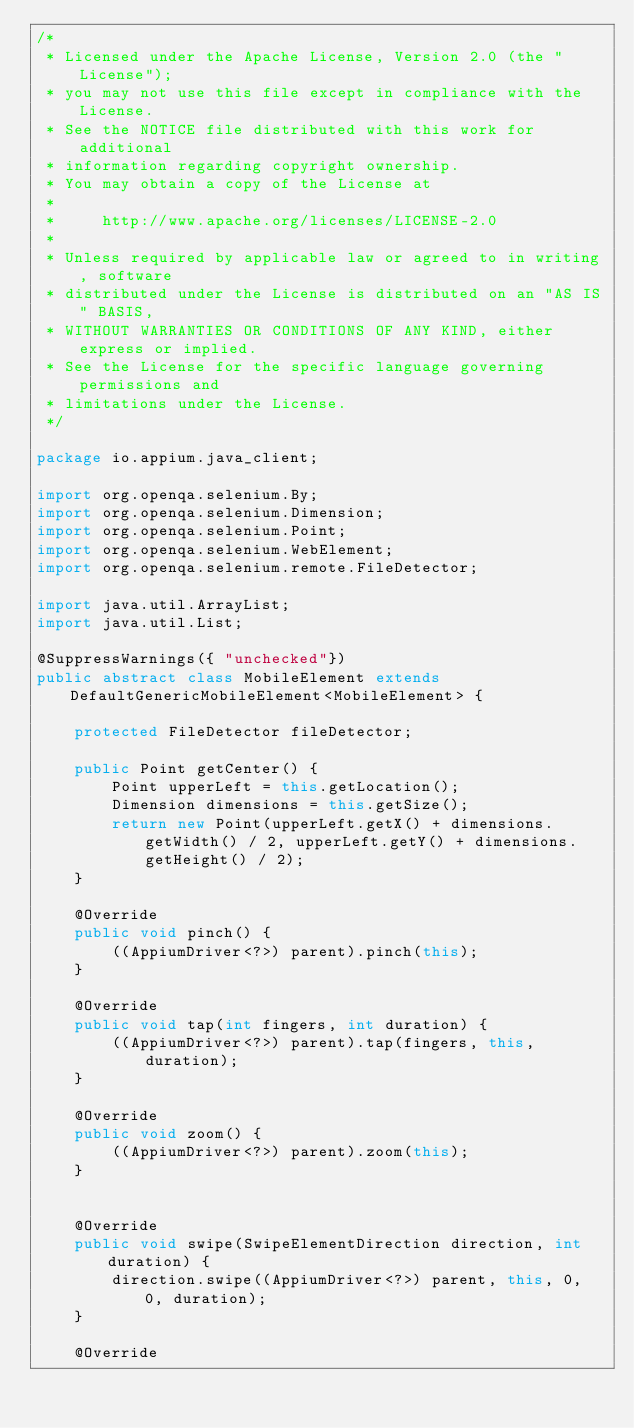<code> <loc_0><loc_0><loc_500><loc_500><_Java_>/*
 * Licensed under the Apache License, Version 2.0 (the "License");
 * you may not use this file except in compliance with the License.
 * See the NOTICE file distributed with this work for additional
 * information regarding copyright ownership.
 * You may obtain a copy of the License at
 *
 *     http://www.apache.org/licenses/LICENSE-2.0
 *
 * Unless required by applicable law or agreed to in writing, software
 * distributed under the License is distributed on an "AS IS" BASIS,
 * WITHOUT WARRANTIES OR CONDITIONS OF ANY KIND, either express or implied.
 * See the License for the specific language governing permissions and
 * limitations under the License.
 */

package io.appium.java_client;

import org.openqa.selenium.By;
import org.openqa.selenium.Dimension;
import org.openqa.selenium.Point;
import org.openqa.selenium.WebElement;
import org.openqa.selenium.remote.FileDetector;

import java.util.ArrayList;
import java.util.List;

@SuppressWarnings({ "unchecked"})
public abstract class MobileElement extends DefaultGenericMobileElement<MobileElement> {

    protected FileDetector fileDetector;

    public Point getCenter() {
        Point upperLeft = this.getLocation();
        Dimension dimensions = this.getSize();
        return new Point(upperLeft.getX() + dimensions.getWidth() / 2, upperLeft.getY() + dimensions.getHeight() / 2);
    }

    @Override
    public void pinch() {
        ((AppiumDriver<?>) parent).pinch(this);
    }

    @Override
    public void tap(int fingers, int duration) {
        ((AppiumDriver<?>) parent).tap(fingers, this, duration);
    }

    @Override
    public void zoom() {
        ((AppiumDriver<?>) parent).zoom(this);
    }


    @Override
    public void swipe(SwipeElementDirection direction, int duration) {
        direction.swipe((AppiumDriver<?>) parent, this, 0, 0, duration);
    }

    @Override</code> 